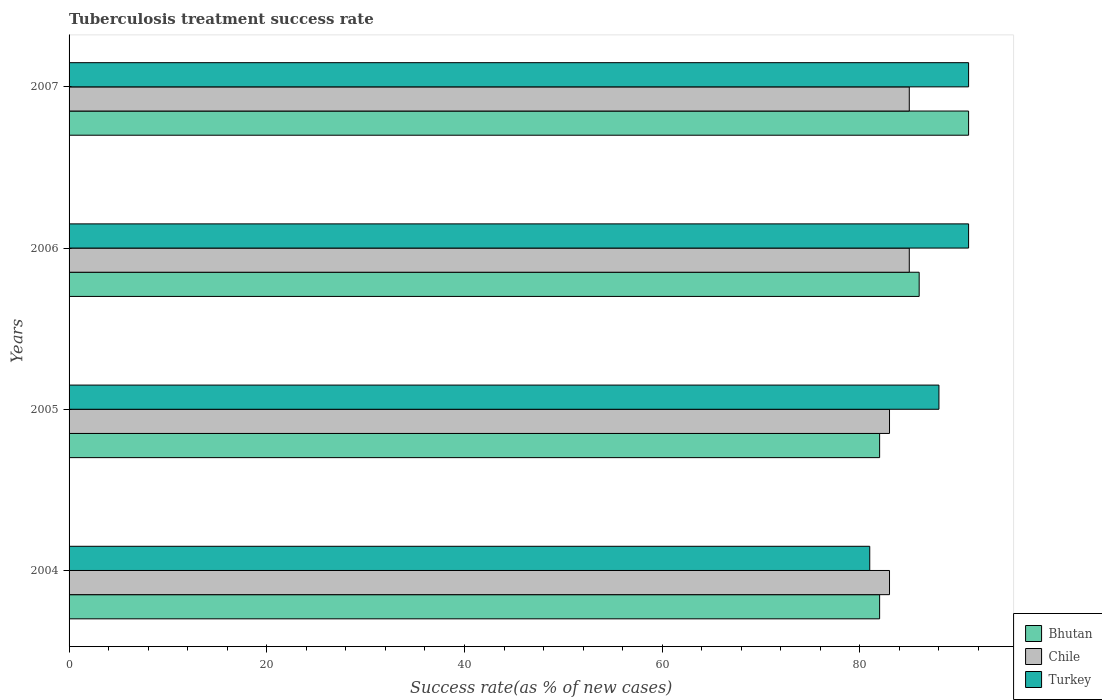Are the number of bars per tick equal to the number of legend labels?
Make the answer very short. Yes. How many bars are there on the 4th tick from the top?
Your response must be concise. 3. In how many cases, is the number of bars for a given year not equal to the number of legend labels?
Your response must be concise. 0. What is the tuberculosis treatment success rate in Bhutan in 2005?
Ensure brevity in your answer.  82. Across all years, what is the maximum tuberculosis treatment success rate in Chile?
Your answer should be compact. 85. Across all years, what is the minimum tuberculosis treatment success rate in Bhutan?
Provide a succinct answer. 82. What is the total tuberculosis treatment success rate in Bhutan in the graph?
Your answer should be compact. 341. What is the difference between the tuberculosis treatment success rate in Bhutan in 2004 and that in 2006?
Keep it short and to the point. -4. What is the difference between the tuberculosis treatment success rate in Turkey in 2004 and the tuberculosis treatment success rate in Chile in 2007?
Offer a terse response. -4. What is the average tuberculosis treatment success rate in Chile per year?
Ensure brevity in your answer.  84. In the year 2005, what is the difference between the tuberculosis treatment success rate in Turkey and tuberculosis treatment success rate in Chile?
Provide a succinct answer. 5. In how many years, is the tuberculosis treatment success rate in Chile greater than 60 %?
Ensure brevity in your answer.  4. What is the ratio of the tuberculosis treatment success rate in Turkey in 2004 to that in 2005?
Your answer should be compact. 0.92. Is the difference between the tuberculosis treatment success rate in Turkey in 2006 and 2007 greater than the difference between the tuberculosis treatment success rate in Chile in 2006 and 2007?
Your answer should be very brief. No. What is the difference between the highest and the second highest tuberculosis treatment success rate in Bhutan?
Your answer should be very brief. 5. What is the difference between the highest and the lowest tuberculosis treatment success rate in Bhutan?
Offer a very short reply. 9. In how many years, is the tuberculosis treatment success rate in Turkey greater than the average tuberculosis treatment success rate in Turkey taken over all years?
Your answer should be compact. 3. Is the sum of the tuberculosis treatment success rate in Bhutan in 2004 and 2007 greater than the maximum tuberculosis treatment success rate in Chile across all years?
Your answer should be very brief. Yes. What does the 3rd bar from the top in 2007 represents?
Provide a short and direct response. Bhutan. What does the 1st bar from the bottom in 2004 represents?
Your answer should be compact. Bhutan. Is it the case that in every year, the sum of the tuberculosis treatment success rate in Chile and tuberculosis treatment success rate in Turkey is greater than the tuberculosis treatment success rate in Bhutan?
Your response must be concise. Yes. How many bars are there?
Offer a very short reply. 12. What is the difference between two consecutive major ticks on the X-axis?
Your answer should be compact. 20. Does the graph contain any zero values?
Give a very brief answer. No. Does the graph contain grids?
Your answer should be very brief. No. Where does the legend appear in the graph?
Your answer should be very brief. Bottom right. How many legend labels are there?
Provide a short and direct response. 3. How are the legend labels stacked?
Offer a terse response. Vertical. What is the title of the graph?
Offer a very short reply. Tuberculosis treatment success rate. Does "Costa Rica" appear as one of the legend labels in the graph?
Your answer should be very brief. No. What is the label or title of the X-axis?
Ensure brevity in your answer.  Success rate(as % of new cases). What is the Success rate(as % of new cases) of Bhutan in 2004?
Provide a succinct answer. 82. What is the Success rate(as % of new cases) in Bhutan in 2005?
Your answer should be very brief. 82. What is the Success rate(as % of new cases) of Turkey in 2005?
Your answer should be very brief. 88. What is the Success rate(as % of new cases) in Bhutan in 2006?
Offer a very short reply. 86. What is the Success rate(as % of new cases) of Turkey in 2006?
Give a very brief answer. 91. What is the Success rate(as % of new cases) in Bhutan in 2007?
Make the answer very short. 91. What is the Success rate(as % of new cases) of Turkey in 2007?
Offer a terse response. 91. Across all years, what is the maximum Success rate(as % of new cases) in Bhutan?
Your response must be concise. 91. Across all years, what is the maximum Success rate(as % of new cases) in Chile?
Give a very brief answer. 85. Across all years, what is the maximum Success rate(as % of new cases) in Turkey?
Ensure brevity in your answer.  91. Across all years, what is the minimum Success rate(as % of new cases) in Bhutan?
Your response must be concise. 82. What is the total Success rate(as % of new cases) of Bhutan in the graph?
Make the answer very short. 341. What is the total Success rate(as % of new cases) of Chile in the graph?
Make the answer very short. 336. What is the total Success rate(as % of new cases) of Turkey in the graph?
Keep it short and to the point. 351. What is the difference between the Success rate(as % of new cases) in Bhutan in 2004 and that in 2005?
Your response must be concise. 0. What is the difference between the Success rate(as % of new cases) in Chile in 2004 and that in 2005?
Make the answer very short. 0. What is the difference between the Success rate(as % of new cases) of Turkey in 2004 and that in 2005?
Your answer should be very brief. -7. What is the difference between the Success rate(as % of new cases) in Bhutan in 2004 and that in 2006?
Provide a succinct answer. -4. What is the difference between the Success rate(as % of new cases) in Chile in 2004 and that in 2006?
Provide a short and direct response. -2. What is the difference between the Success rate(as % of new cases) in Turkey in 2004 and that in 2006?
Provide a succinct answer. -10. What is the difference between the Success rate(as % of new cases) in Bhutan in 2004 and that in 2007?
Provide a short and direct response. -9. What is the difference between the Success rate(as % of new cases) of Chile in 2004 and that in 2007?
Offer a very short reply. -2. What is the difference between the Success rate(as % of new cases) of Turkey in 2004 and that in 2007?
Provide a short and direct response. -10. What is the difference between the Success rate(as % of new cases) in Bhutan in 2005 and that in 2006?
Provide a succinct answer. -4. What is the difference between the Success rate(as % of new cases) of Chile in 2005 and that in 2006?
Offer a terse response. -2. What is the difference between the Success rate(as % of new cases) in Turkey in 2005 and that in 2006?
Offer a terse response. -3. What is the difference between the Success rate(as % of new cases) of Bhutan in 2006 and that in 2007?
Ensure brevity in your answer.  -5. What is the difference between the Success rate(as % of new cases) of Turkey in 2006 and that in 2007?
Provide a succinct answer. 0. What is the difference between the Success rate(as % of new cases) of Bhutan in 2004 and the Success rate(as % of new cases) of Chile in 2005?
Your response must be concise. -1. What is the difference between the Success rate(as % of new cases) of Bhutan in 2004 and the Success rate(as % of new cases) of Chile in 2006?
Your response must be concise. -3. What is the difference between the Success rate(as % of new cases) of Bhutan in 2004 and the Success rate(as % of new cases) of Turkey in 2006?
Offer a terse response. -9. What is the difference between the Success rate(as % of new cases) of Bhutan in 2004 and the Success rate(as % of new cases) of Chile in 2007?
Your answer should be very brief. -3. What is the difference between the Success rate(as % of new cases) of Bhutan in 2004 and the Success rate(as % of new cases) of Turkey in 2007?
Your response must be concise. -9. What is the difference between the Success rate(as % of new cases) in Chile in 2004 and the Success rate(as % of new cases) in Turkey in 2007?
Your answer should be compact. -8. What is the difference between the Success rate(as % of new cases) of Bhutan in 2005 and the Success rate(as % of new cases) of Turkey in 2006?
Provide a short and direct response. -9. What is the difference between the Success rate(as % of new cases) of Chile in 2005 and the Success rate(as % of new cases) of Turkey in 2006?
Provide a succinct answer. -8. What is the difference between the Success rate(as % of new cases) in Bhutan in 2005 and the Success rate(as % of new cases) in Chile in 2007?
Give a very brief answer. -3. What is the difference between the Success rate(as % of new cases) of Chile in 2005 and the Success rate(as % of new cases) of Turkey in 2007?
Make the answer very short. -8. What is the difference between the Success rate(as % of new cases) of Bhutan in 2006 and the Success rate(as % of new cases) of Chile in 2007?
Ensure brevity in your answer.  1. What is the difference between the Success rate(as % of new cases) of Bhutan in 2006 and the Success rate(as % of new cases) of Turkey in 2007?
Make the answer very short. -5. What is the average Success rate(as % of new cases) of Bhutan per year?
Keep it short and to the point. 85.25. What is the average Success rate(as % of new cases) of Chile per year?
Your answer should be compact. 84. What is the average Success rate(as % of new cases) of Turkey per year?
Provide a short and direct response. 87.75. In the year 2005, what is the difference between the Success rate(as % of new cases) of Bhutan and Success rate(as % of new cases) of Chile?
Provide a short and direct response. -1. In the year 2005, what is the difference between the Success rate(as % of new cases) in Chile and Success rate(as % of new cases) in Turkey?
Provide a short and direct response. -5. In the year 2006, what is the difference between the Success rate(as % of new cases) in Bhutan and Success rate(as % of new cases) in Turkey?
Keep it short and to the point. -5. In the year 2007, what is the difference between the Success rate(as % of new cases) in Bhutan and Success rate(as % of new cases) in Turkey?
Provide a short and direct response. 0. In the year 2007, what is the difference between the Success rate(as % of new cases) in Chile and Success rate(as % of new cases) in Turkey?
Offer a terse response. -6. What is the ratio of the Success rate(as % of new cases) of Chile in 2004 to that in 2005?
Provide a short and direct response. 1. What is the ratio of the Success rate(as % of new cases) of Turkey in 2004 to that in 2005?
Make the answer very short. 0.92. What is the ratio of the Success rate(as % of new cases) of Bhutan in 2004 to that in 2006?
Make the answer very short. 0.95. What is the ratio of the Success rate(as % of new cases) of Chile in 2004 to that in 2006?
Your answer should be very brief. 0.98. What is the ratio of the Success rate(as % of new cases) in Turkey in 2004 to that in 2006?
Make the answer very short. 0.89. What is the ratio of the Success rate(as % of new cases) in Bhutan in 2004 to that in 2007?
Ensure brevity in your answer.  0.9. What is the ratio of the Success rate(as % of new cases) of Chile in 2004 to that in 2007?
Ensure brevity in your answer.  0.98. What is the ratio of the Success rate(as % of new cases) in Turkey in 2004 to that in 2007?
Ensure brevity in your answer.  0.89. What is the ratio of the Success rate(as % of new cases) in Bhutan in 2005 to that in 2006?
Keep it short and to the point. 0.95. What is the ratio of the Success rate(as % of new cases) of Chile in 2005 to that in 2006?
Offer a very short reply. 0.98. What is the ratio of the Success rate(as % of new cases) in Bhutan in 2005 to that in 2007?
Offer a very short reply. 0.9. What is the ratio of the Success rate(as % of new cases) of Chile in 2005 to that in 2007?
Your response must be concise. 0.98. What is the ratio of the Success rate(as % of new cases) in Turkey in 2005 to that in 2007?
Provide a succinct answer. 0.97. What is the ratio of the Success rate(as % of new cases) of Bhutan in 2006 to that in 2007?
Provide a short and direct response. 0.95. What is the ratio of the Success rate(as % of new cases) in Chile in 2006 to that in 2007?
Provide a succinct answer. 1. What is the difference between the highest and the second highest Success rate(as % of new cases) of Bhutan?
Your response must be concise. 5. What is the difference between the highest and the second highest Success rate(as % of new cases) of Chile?
Your answer should be very brief. 0. What is the difference between the highest and the second highest Success rate(as % of new cases) in Turkey?
Provide a succinct answer. 0. What is the difference between the highest and the lowest Success rate(as % of new cases) of Bhutan?
Provide a succinct answer. 9. 